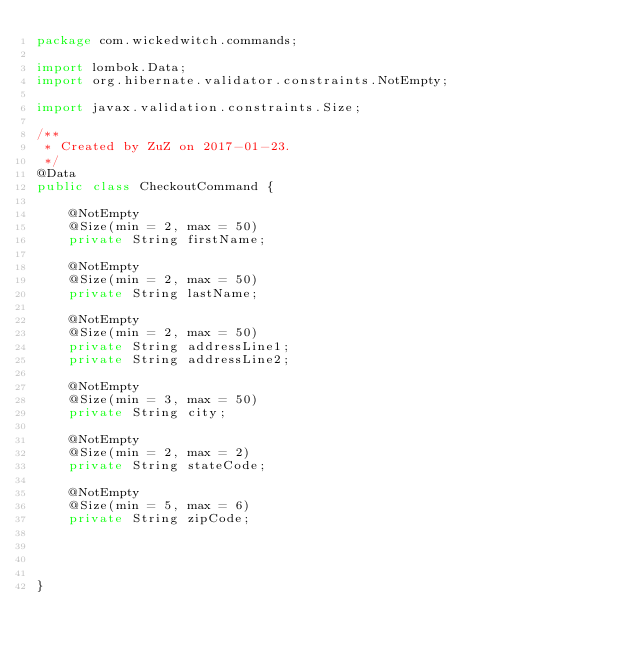Convert code to text. <code><loc_0><loc_0><loc_500><loc_500><_Java_>package com.wickedwitch.commands;

import lombok.Data;
import org.hibernate.validator.constraints.NotEmpty;

import javax.validation.constraints.Size;

/**
 * Created by ZuZ on 2017-01-23.
 */
@Data
public class CheckoutCommand {

    @NotEmpty
    @Size(min = 2, max = 50)
    private String firstName;

    @NotEmpty
    @Size(min = 2, max = 50)
    private String lastName;

    @NotEmpty
    @Size(min = 2, max = 50)
    private String addressLine1;
    private String addressLine2;

    @NotEmpty
    @Size(min = 3, max = 50)
    private String city;

    @NotEmpty
    @Size(min = 2, max = 2)
    private String stateCode;

    @NotEmpty
    @Size(min = 5, max = 6)
    private String zipCode;




}
</code> 